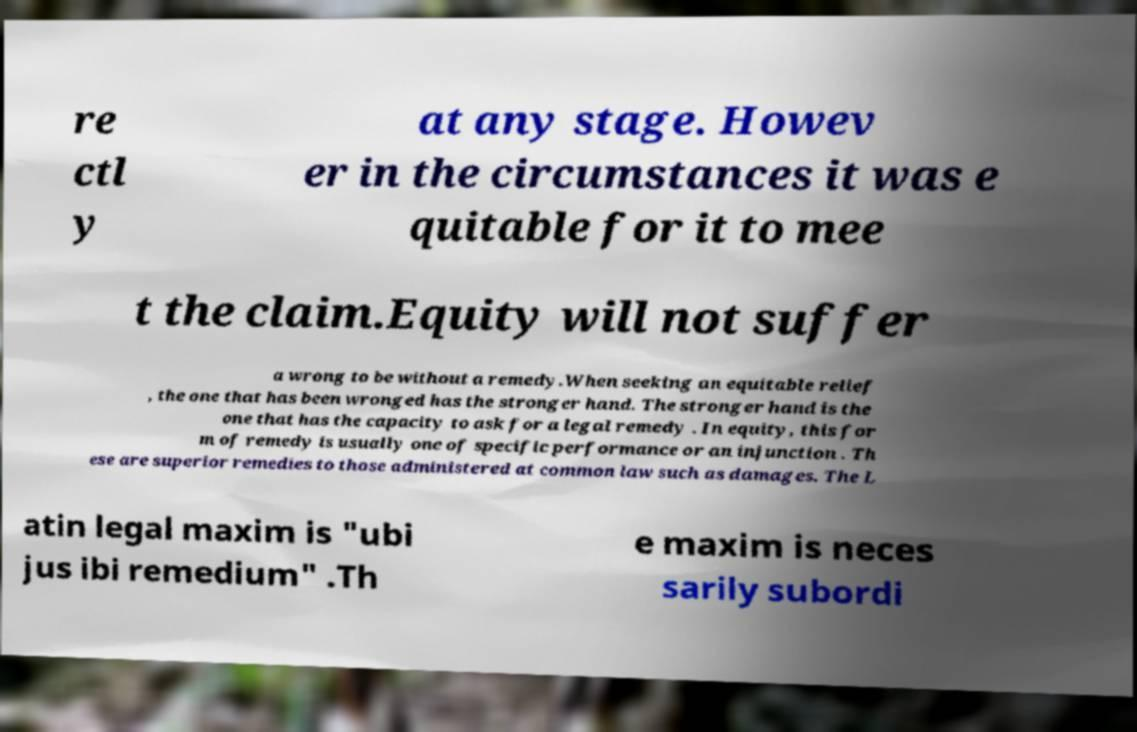Can you accurately transcribe the text from the provided image for me? re ctl y at any stage. Howev er in the circumstances it was e quitable for it to mee t the claim.Equity will not suffer a wrong to be without a remedy.When seeking an equitable relief , the one that has been wronged has the stronger hand. The stronger hand is the one that has the capacity to ask for a legal remedy . In equity, this for m of remedy is usually one of specific performance or an injunction . Th ese are superior remedies to those administered at common law such as damages. The L atin legal maxim is "ubi jus ibi remedium" .Th e maxim is neces sarily subordi 